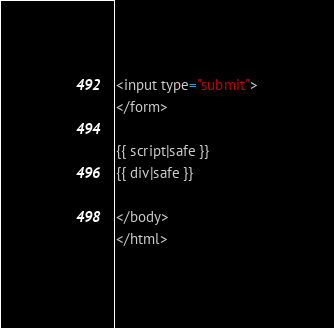<code> <loc_0><loc_0><loc_500><loc_500><_HTML_><input type="submit">
</form>

{{ script|safe }}
{{ div|safe }}

</body>
</html></code> 